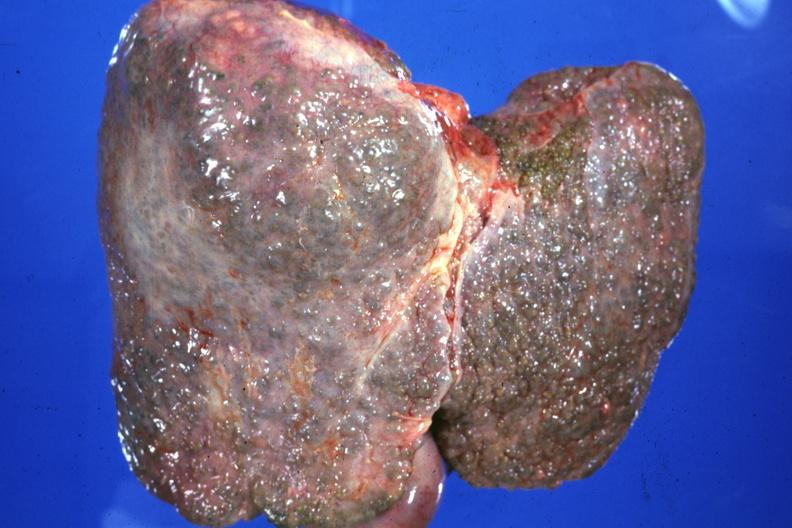s hepatobiliary present?
Answer the question using a single word or phrase. Yes 